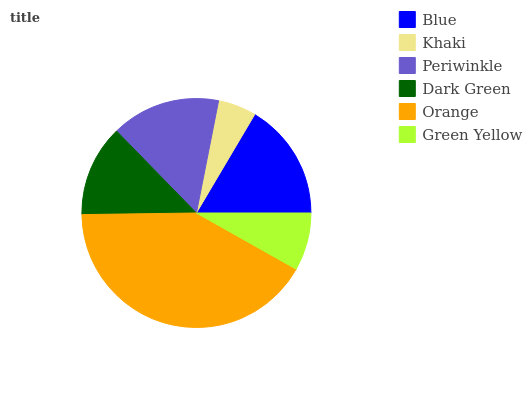Is Khaki the minimum?
Answer yes or no. Yes. Is Orange the maximum?
Answer yes or no. Yes. Is Periwinkle the minimum?
Answer yes or no. No. Is Periwinkle the maximum?
Answer yes or no. No. Is Periwinkle greater than Khaki?
Answer yes or no. Yes. Is Khaki less than Periwinkle?
Answer yes or no. Yes. Is Khaki greater than Periwinkle?
Answer yes or no. No. Is Periwinkle less than Khaki?
Answer yes or no. No. Is Periwinkle the high median?
Answer yes or no. Yes. Is Dark Green the low median?
Answer yes or no. Yes. Is Khaki the high median?
Answer yes or no. No. Is Green Yellow the low median?
Answer yes or no. No. 